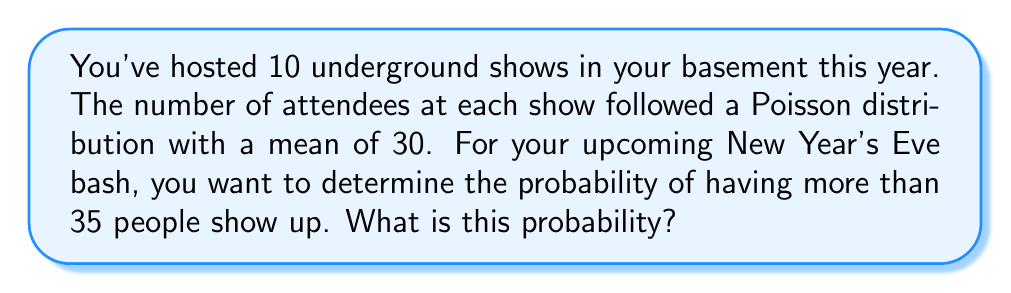What is the answer to this math problem? Let's approach this step-by-step:

1) We're dealing with a Poisson distribution with mean $\lambda = 30$.

2) We want to find $P(X > 35)$, where $X$ is the number of attendees.

3) This is equivalent to $1 - P(X \leq 35)$.

4) For a Poisson distribution, the probability of $X \leq k$ is given by:

   $$P(X \leq k) = e^{-\lambda} \sum_{i=0}^k \frac{\lambda^i}{i!}$$

5) In our case, $k = 35$ and $\lambda = 30$:

   $$P(X \leq 35) = e^{-30} \sum_{i=0}^{35} \frac{30^i}{i!}$$

6) This sum is difficult to calculate by hand, so we typically use statistical software or tables. Using such tools, we find:

   $$P(X \leq 35) \approx 0.8562$$

7) Therefore, $P(X > 35) = 1 - P(X \leq 35) = 1 - 0.8562 = 0.1438$

So, the probability of having more than 35 people show up is approximately 0.1438 or 14.38%.
Answer: 0.1438 